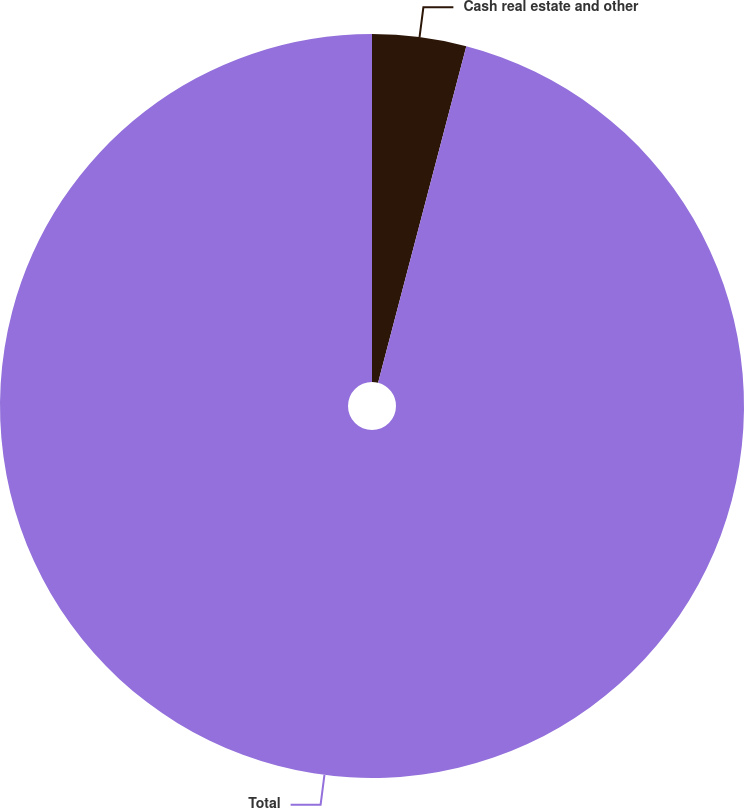Convert chart. <chart><loc_0><loc_0><loc_500><loc_500><pie_chart><fcel>Cash real estate and other<fcel>Total<nl><fcel>4.08%<fcel>95.92%<nl></chart> 